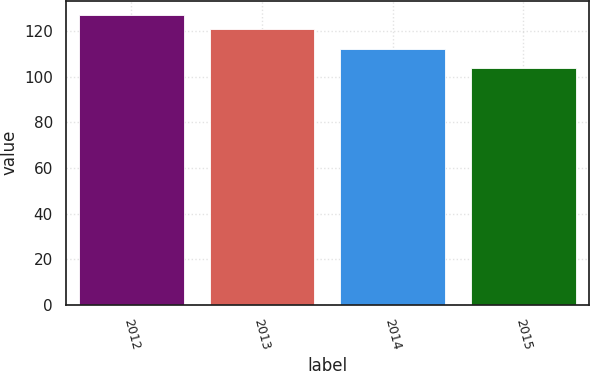<chart> <loc_0><loc_0><loc_500><loc_500><bar_chart><fcel>2012<fcel>2013<fcel>2014<fcel>2015<nl><fcel>127<fcel>121<fcel>112<fcel>104<nl></chart> 